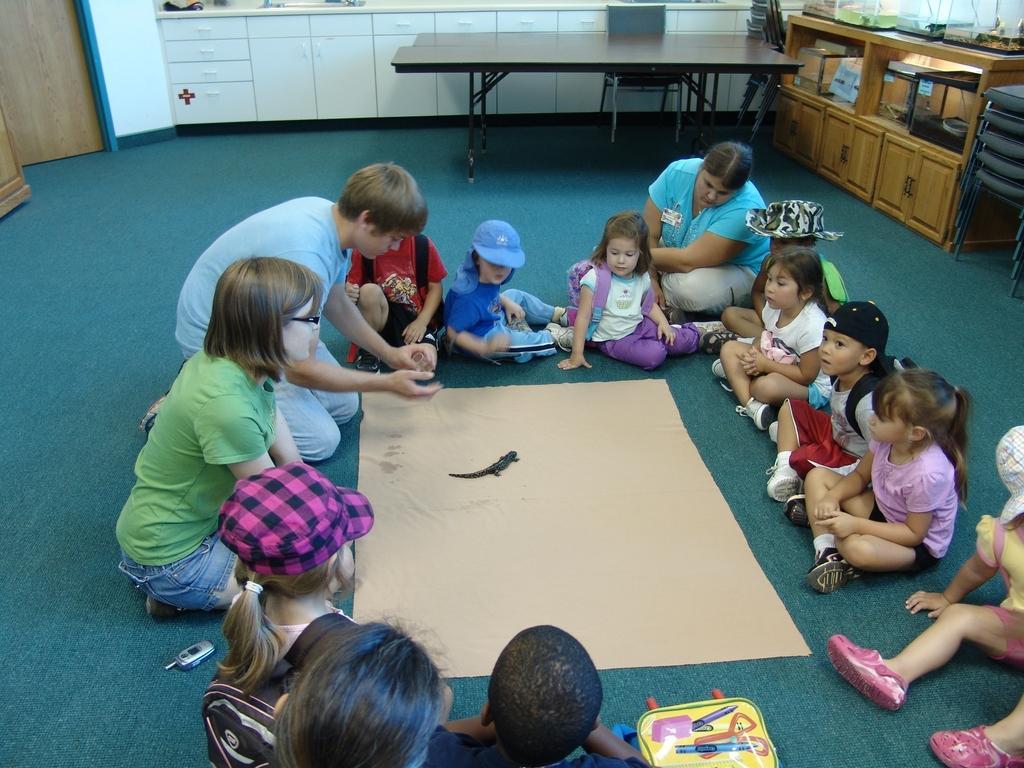Please provide a concise description of this image. This picture shows a group of children seated on the floor and we see a paper on the floor and a woman among them and a table 